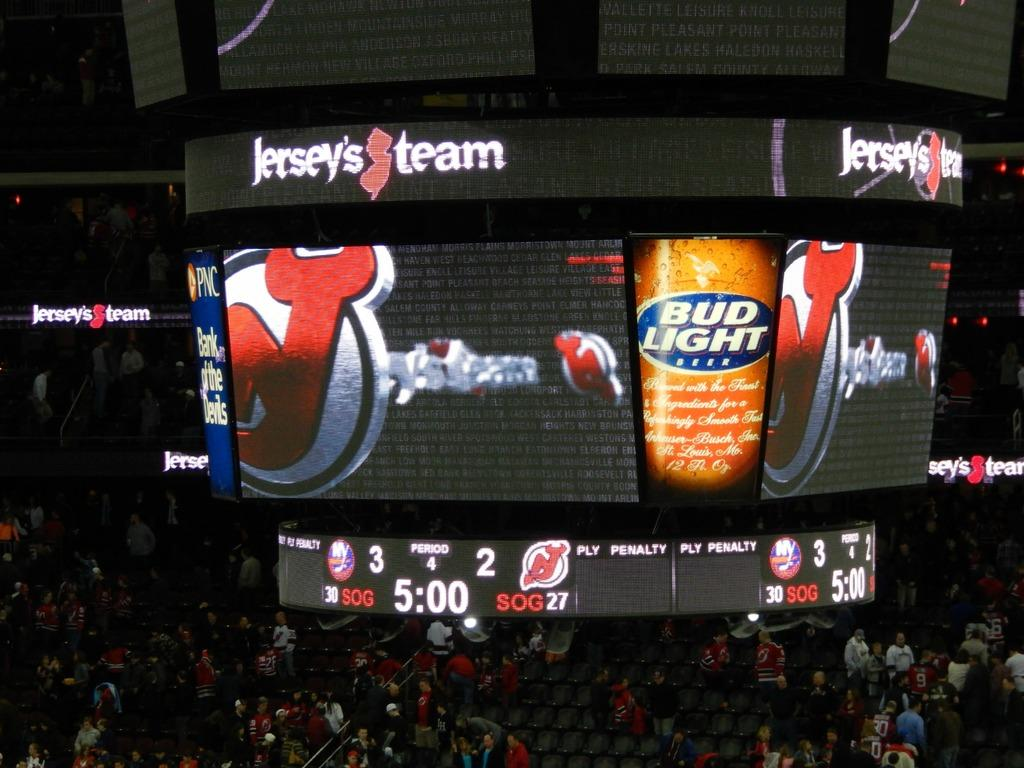<image>
Share a concise interpretation of the image provided. a scoreboard in a stadium that says 'jersey's team' on it 